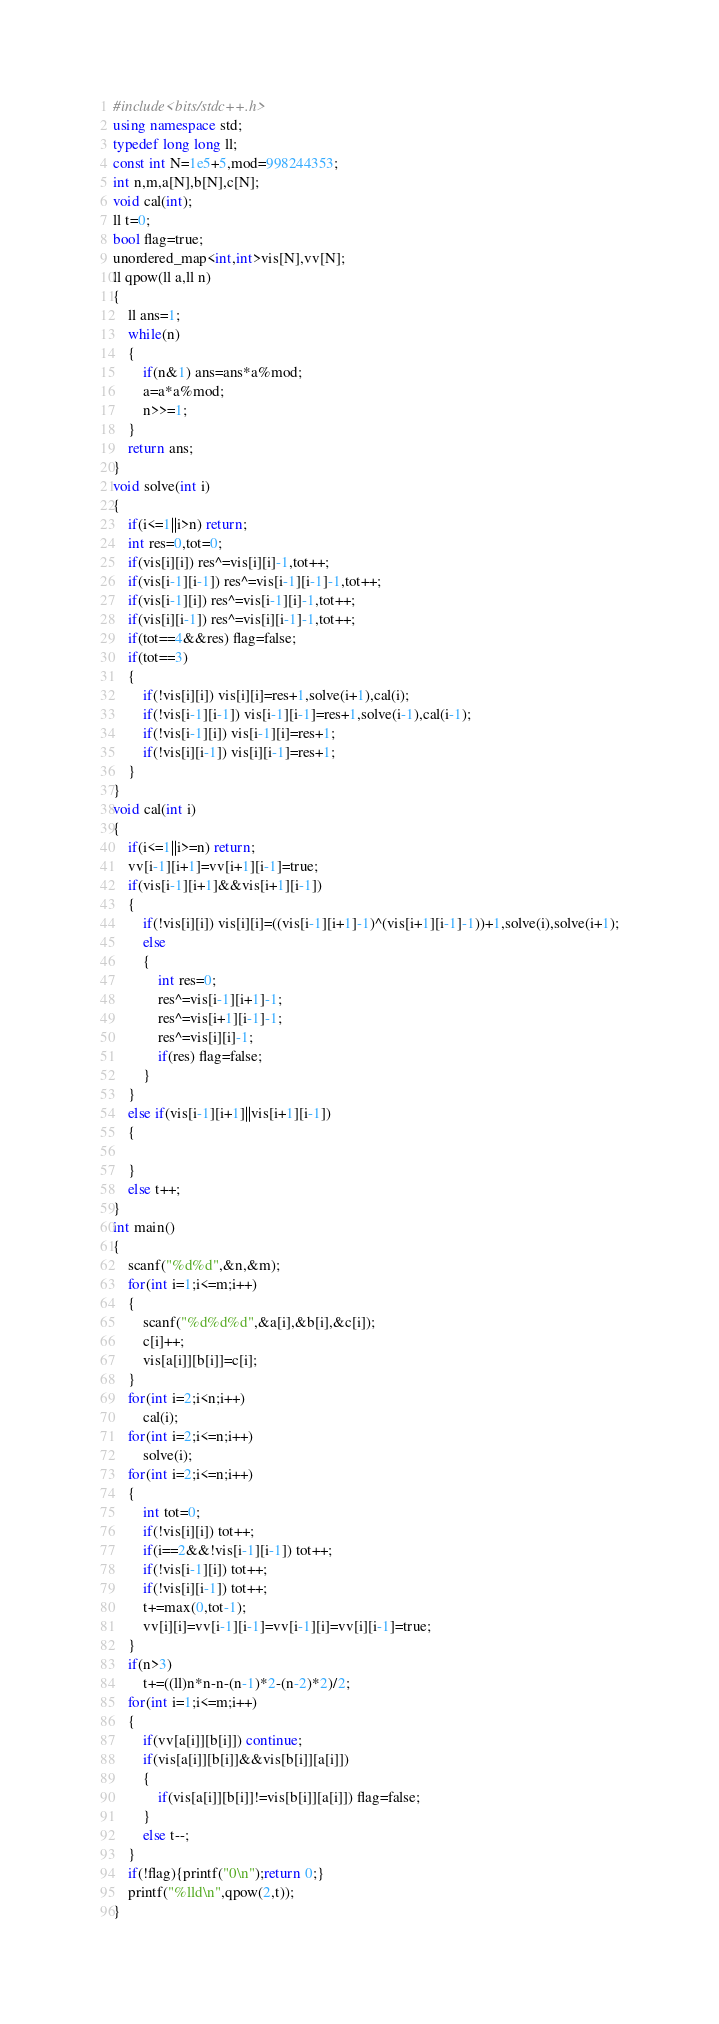<code> <loc_0><loc_0><loc_500><loc_500><_C++_>#include<bits/stdc++.h>
using namespace std;
typedef long long ll;
const int N=1e5+5,mod=998244353;
int n,m,a[N],b[N],c[N];
void cal(int);
ll t=0;
bool flag=true;
unordered_map<int,int>vis[N],vv[N];
ll qpow(ll a,ll n)
{
    ll ans=1;
    while(n)
    {
        if(n&1) ans=ans*a%mod;
        a=a*a%mod;
        n>>=1;
    }
    return ans;
}
void solve(int i)
{
    if(i<=1||i>n) return;
    int res=0,tot=0;
    if(vis[i][i]) res^=vis[i][i]-1,tot++;
    if(vis[i-1][i-1]) res^=vis[i-1][i-1]-1,tot++;
    if(vis[i-1][i]) res^=vis[i-1][i]-1,tot++;
    if(vis[i][i-1]) res^=vis[i][i-1]-1,tot++;
    if(tot==4&&res) flag=false;
    if(tot==3)
    {
        if(!vis[i][i]) vis[i][i]=res+1,solve(i+1),cal(i);
        if(!vis[i-1][i-1]) vis[i-1][i-1]=res+1,solve(i-1),cal(i-1);
        if(!vis[i-1][i]) vis[i-1][i]=res+1;
        if(!vis[i][i-1]) vis[i][i-1]=res+1;
    }
}
void cal(int i)
{
    if(i<=1||i>=n) return;
    vv[i-1][i+1]=vv[i+1][i-1]=true;
    if(vis[i-1][i+1]&&vis[i+1][i-1])
    {
        if(!vis[i][i]) vis[i][i]=((vis[i-1][i+1]-1)^(vis[i+1][i-1]-1))+1,solve(i),solve(i+1);
        else
        {
            int res=0;
            res^=vis[i-1][i+1]-1;
            res^=vis[i+1][i-1]-1;
            res^=vis[i][i]-1;
            if(res) flag=false;
        }
    }
    else if(vis[i-1][i+1]||vis[i+1][i-1])
    {

    }
    else t++;
}
int main()
{
    scanf("%d%d",&n,&m);
    for(int i=1;i<=m;i++)
    {
        scanf("%d%d%d",&a[i],&b[i],&c[i]);
        c[i]++;
        vis[a[i]][b[i]]=c[i];
    }
    for(int i=2;i<n;i++)
        cal(i);
    for(int i=2;i<=n;i++)
        solve(i);
    for(int i=2;i<=n;i++)
    {
        int tot=0;
        if(!vis[i][i]) tot++;
        if(i==2&&!vis[i-1][i-1]) tot++;
        if(!vis[i-1][i]) tot++;
        if(!vis[i][i-1]) tot++;
        t+=max(0,tot-1);
        vv[i][i]=vv[i-1][i-1]=vv[i-1][i]=vv[i][i-1]=true;
    }
    if(n>3)
        t+=((ll)n*n-n-(n-1)*2-(n-2)*2)/2;
    for(int i=1;i<=m;i++)
    {
        if(vv[a[i]][b[i]]) continue;
        if(vis[a[i]][b[i]]&&vis[b[i]][a[i]])
        {
            if(vis[a[i]][b[i]]!=vis[b[i]][a[i]]) flag=false;
        }
        else t--;
    }
    if(!flag){printf("0\n");return 0;}
    printf("%lld\n",qpow(2,t));
}
</code> 